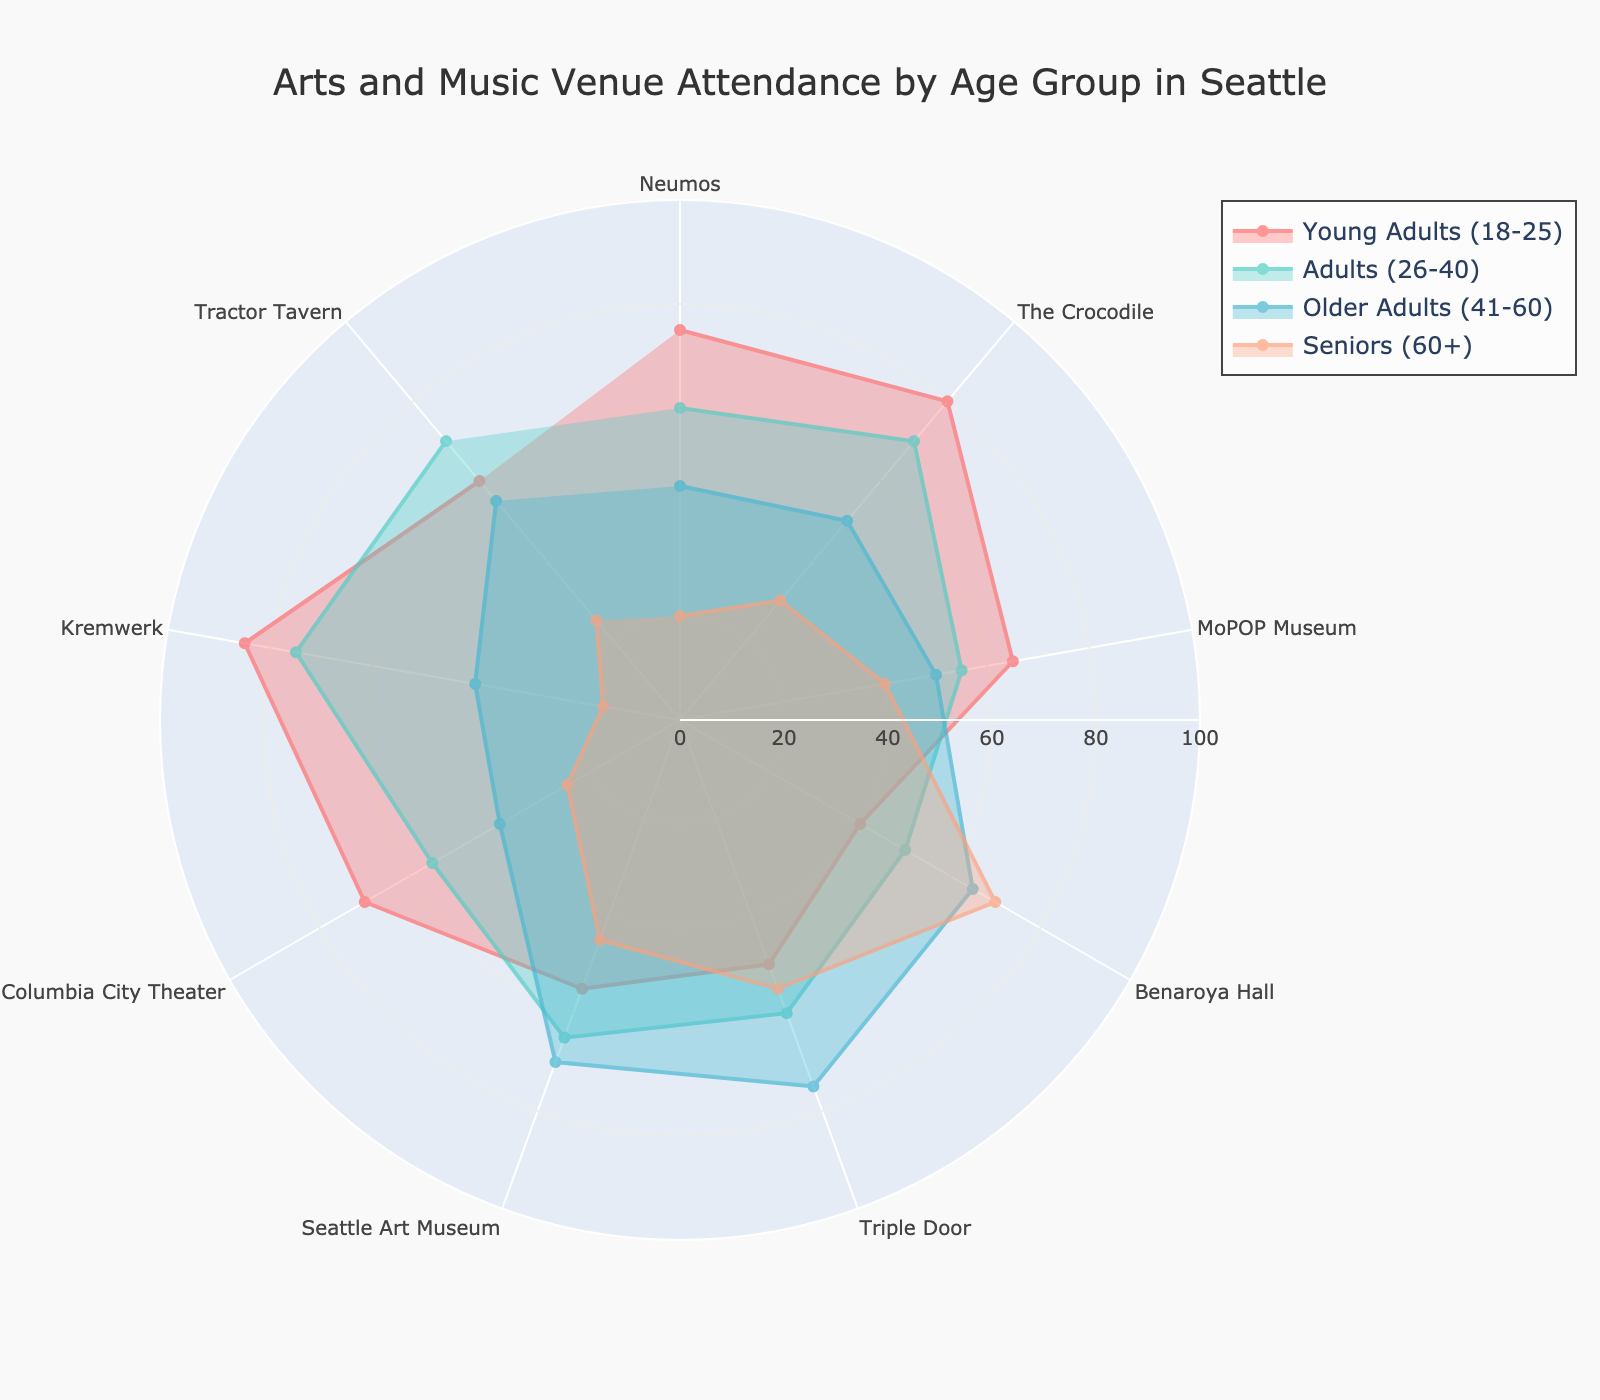What's the title of the radar chart? The title is usually located at the top-middle of the radar chart. For this specific chart, the title reads "Arts and Music Venue Attendance by Age Group in Seattle".
Answer: Arts and Music Venue Attendance by Age Group in Seattle Which venue has the highest attendance among Young Adults (18-25)? By looking at the red section of the radar chart, which represents Young Adults (18-25), the longest extension from the center for this group is towards "Kremwerk".
Answer: Kremwerk Comparing Seniors (60+) attendance, which venue do they visit the most? The opacity area representing Seniors (60+) on the radar chart shows the largest extension towards "Benaroya Hall".
Answer: Benaroya Hall What is the total attendance percentage for Older Adults (41-60) at MoPOP Museum and Seattle Art Museum? To find the total, add the Older Adults (41-60) percentage for MoPOP Museum and Seattle Art Museum from the radar chart. MoPOP Museum shows 50% and Seattle Art Museum shows 70%. So, 50 + 70 = 120.
Answer: 120 Which age group has the least variation in their attendance percentages across all venues? By comparing the spread of the age groups, Seniors (60+) appear to have the least variation; their attendance percentages range relatively close together between 15 and 70.
Answer: Seniors (60+) What is the difference in attendance percentages between Adults (26-40) and Seniors (60+) at The Crocodile? For Adults (26-40), the value is 70, and for Seniors (60+), it is 30 at The Crocodile. The difference is calculated as 70 - 30 = 40.
Answer: 40 Among Triple Door and Seattle Art Museum, which venue has higher attendance by Older Adults (41-60)? Comparing the blue sections, the larger extension for Older Adults (41-60) is towards Seattle Art Museum, with a percentage of 70, compared to 75 at Triple Door.
Answer: Triple Door How does the attendance percentage of Young Adults (18-25) at Columbia City Theater compare to that at Benaroya Hall? Young Adults (18-25) have a 70% attendance at Columbia City Theater and a 40% attendance at Benaroya Hall. Thus, Columbia City Theater has a higher percentage.
Answer: Columbia City Theater What is the range of attendance percentages for Adults (26-40) across all the venues? The highest value for Adults (26-40) is 75 (Kremwerk), and the lowest is 50 (MoPOP Museum), giving a range of 75 - 50 = 25.
Answer: 25 